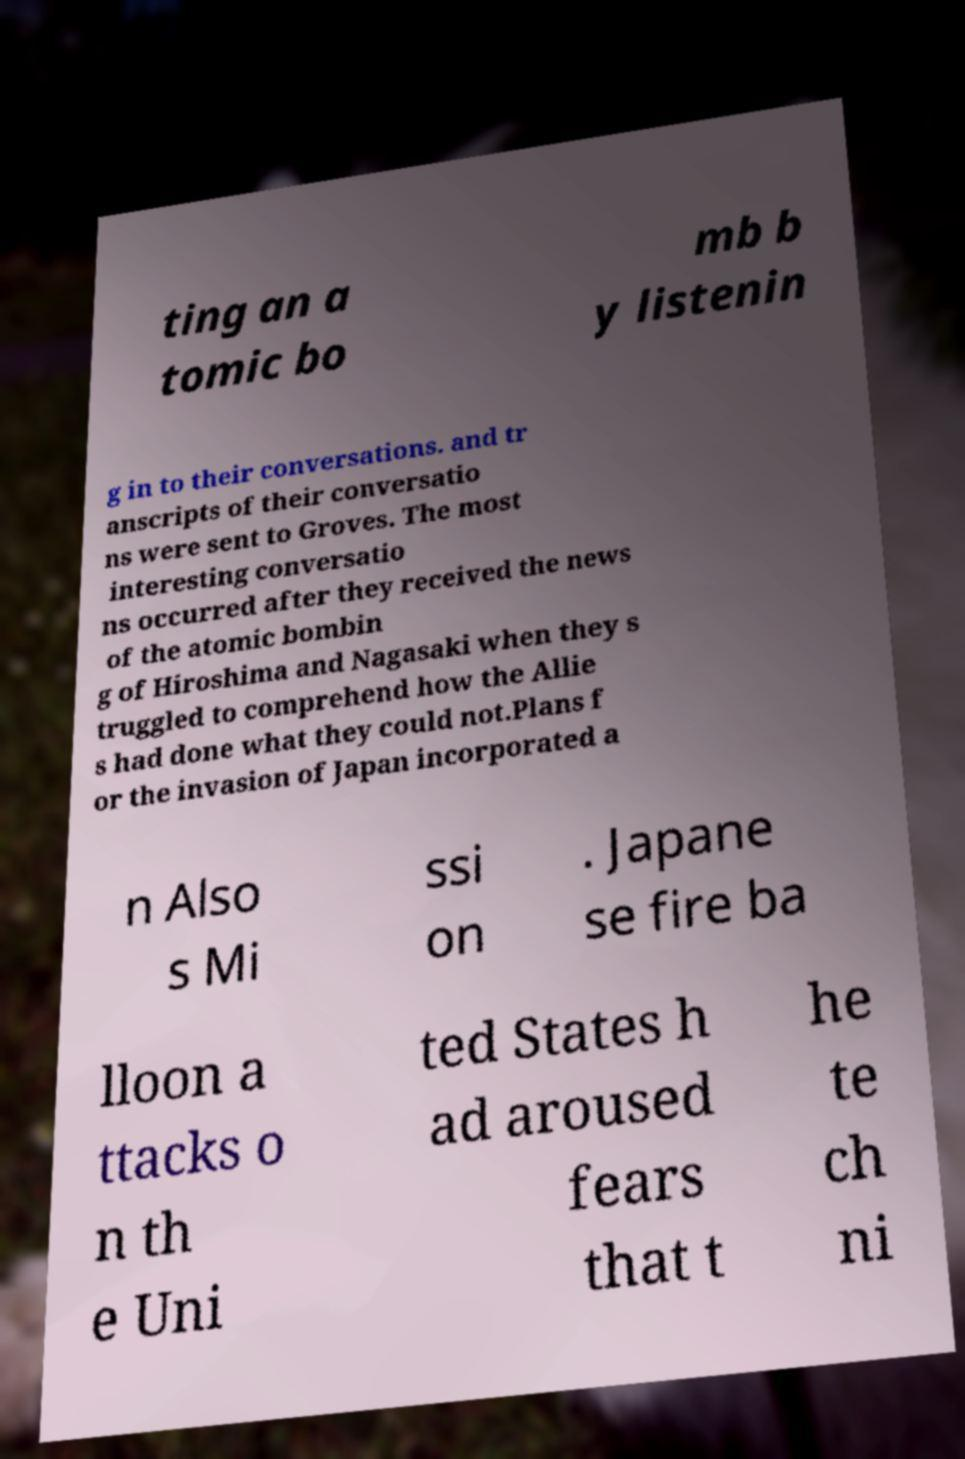Could you extract and type out the text from this image? ting an a tomic bo mb b y listenin g in to their conversations. and tr anscripts of their conversatio ns were sent to Groves. The most interesting conversatio ns occurred after they received the news of the atomic bombin g of Hiroshima and Nagasaki when they s truggled to comprehend how the Allie s had done what they could not.Plans f or the invasion of Japan incorporated a n Also s Mi ssi on . Japane se fire ba lloon a ttacks o n th e Uni ted States h ad aroused fears that t he te ch ni 